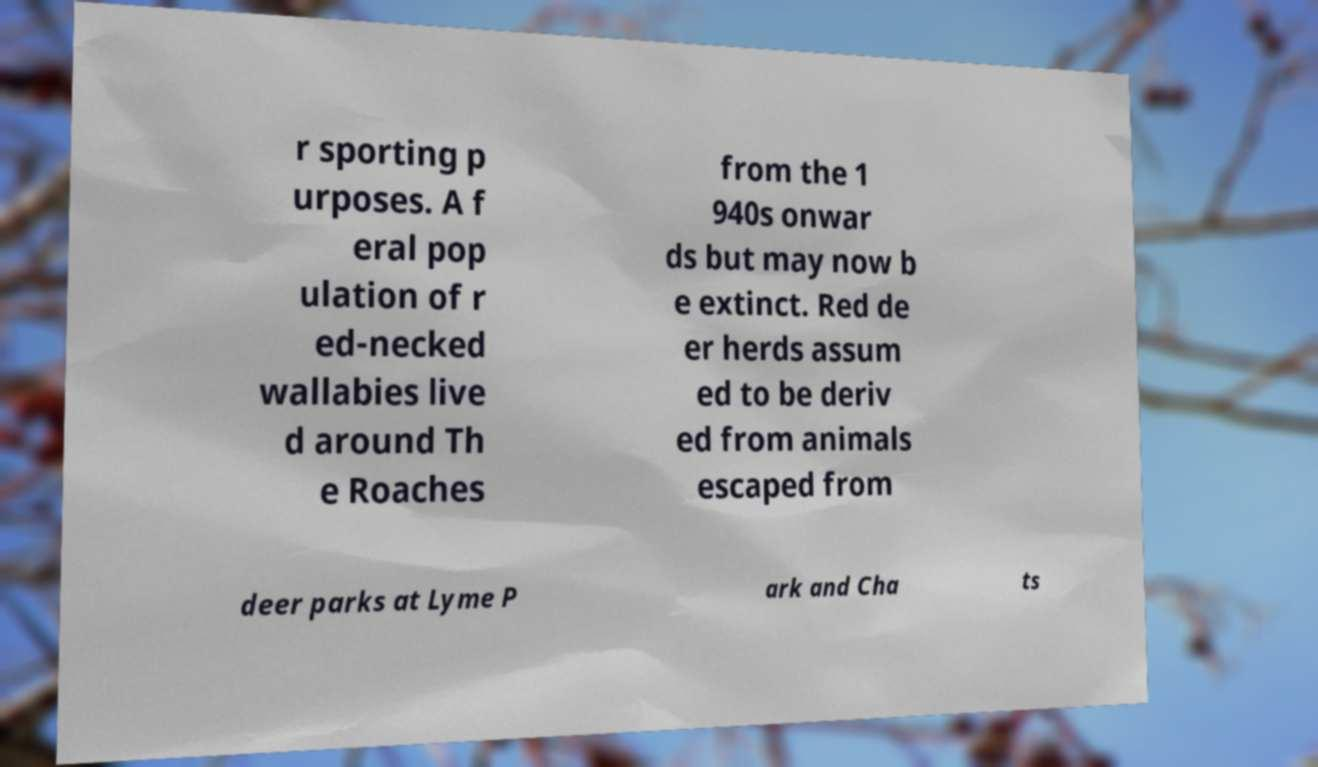Can you read and provide the text displayed in the image?This photo seems to have some interesting text. Can you extract and type it out for me? r sporting p urposes. A f eral pop ulation of r ed-necked wallabies live d around Th e Roaches from the 1 940s onwar ds but may now b e extinct. Red de er herds assum ed to be deriv ed from animals escaped from deer parks at Lyme P ark and Cha ts 